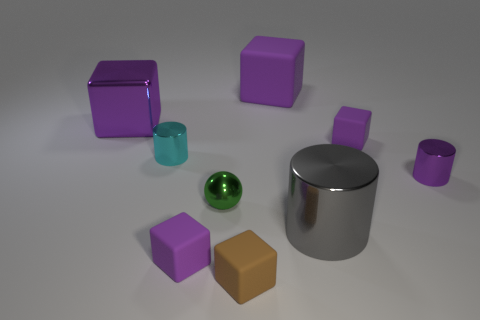Are there any brown rubber objects of the same shape as the green object?
Your response must be concise. No. Does the thing that is to the left of the cyan thing have the same shape as the gray metallic object?
Give a very brief answer. No. How many blocks are behind the small brown rubber cube and in front of the big shiny cube?
Your response must be concise. 2. There is a purple rubber thing that is in front of the tiny cyan object; what shape is it?
Ensure brevity in your answer.  Cube. How many big green spheres have the same material as the tiny green thing?
Give a very brief answer. 0. There is a gray thing; is it the same shape as the rubber thing left of the sphere?
Keep it short and to the point. No. Are there any small cubes behind the purple metal object right of the block left of the tiny cyan object?
Offer a terse response. Yes. How big is the gray object on the right side of the small brown thing?
Give a very brief answer. Large. There is a cyan thing that is the same size as the green shiny ball; what is its material?
Make the answer very short. Metal. Is the shape of the small cyan object the same as the gray metallic thing?
Your response must be concise. Yes. 